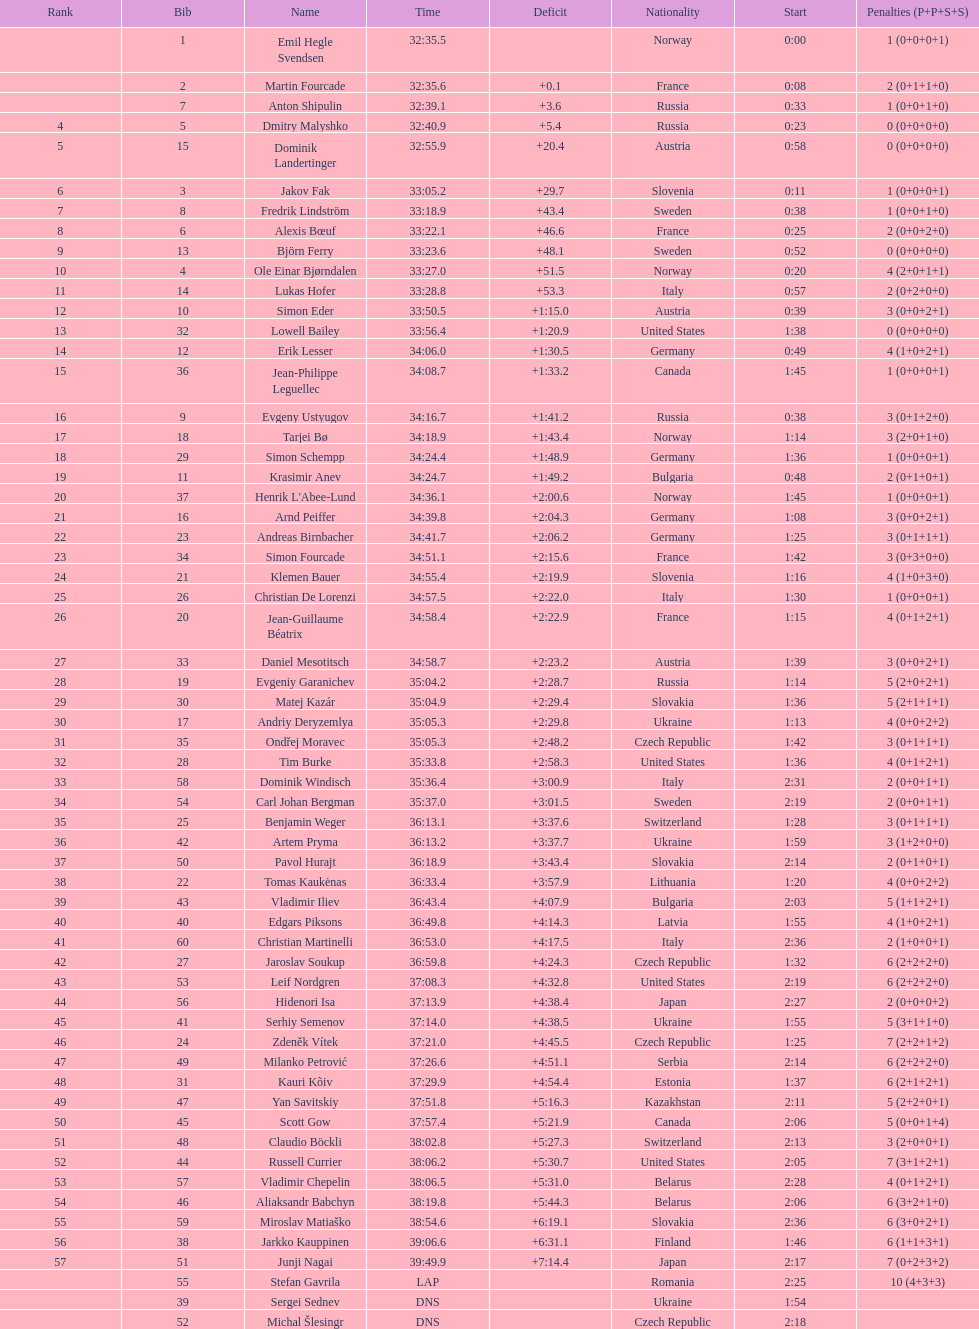How many took at least 35:00 to finish? 30. 